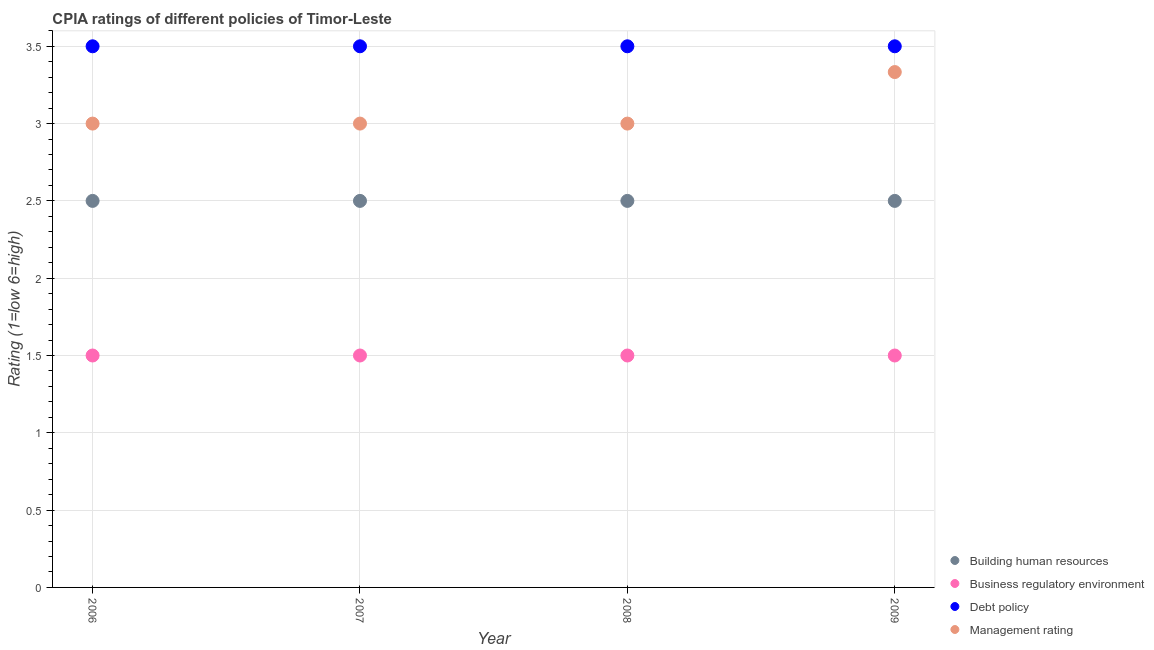How many different coloured dotlines are there?
Provide a short and direct response. 4. What is the cpia rating of building human resources in 2006?
Offer a very short reply. 2.5. Across all years, what is the maximum cpia rating of debt policy?
Your answer should be compact. 3.5. Across all years, what is the minimum cpia rating of debt policy?
Provide a short and direct response. 3.5. In which year was the cpia rating of debt policy maximum?
Give a very brief answer. 2006. In which year was the cpia rating of management minimum?
Ensure brevity in your answer.  2006. What is the total cpia rating of management in the graph?
Provide a succinct answer. 12.33. What is the average cpia rating of management per year?
Give a very brief answer. 3.08. What is the ratio of the cpia rating of debt policy in 2006 to that in 2008?
Provide a short and direct response. 1. Is the cpia rating of management in 2006 less than that in 2008?
Your answer should be compact. No. Is the difference between the cpia rating of building human resources in 2006 and 2008 greater than the difference between the cpia rating of business regulatory environment in 2006 and 2008?
Make the answer very short. No. What is the difference between the highest and the second highest cpia rating of business regulatory environment?
Keep it short and to the point. 0. What is the difference between the highest and the lowest cpia rating of building human resources?
Your response must be concise. 0. In how many years, is the cpia rating of management greater than the average cpia rating of management taken over all years?
Give a very brief answer. 1. Is the sum of the cpia rating of management in 2006 and 2009 greater than the maximum cpia rating of building human resources across all years?
Provide a succinct answer. Yes. Does the cpia rating of management monotonically increase over the years?
Provide a short and direct response. No. Is the cpia rating of debt policy strictly greater than the cpia rating of business regulatory environment over the years?
Keep it short and to the point. Yes. How many dotlines are there?
Provide a succinct answer. 4. How many years are there in the graph?
Your answer should be compact. 4. What is the difference between two consecutive major ticks on the Y-axis?
Ensure brevity in your answer.  0.5. Does the graph contain any zero values?
Ensure brevity in your answer.  No. How are the legend labels stacked?
Provide a succinct answer. Vertical. What is the title of the graph?
Provide a short and direct response. CPIA ratings of different policies of Timor-Leste. Does "Finland" appear as one of the legend labels in the graph?
Ensure brevity in your answer.  No. What is the label or title of the X-axis?
Provide a short and direct response. Year. What is the label or title of the Y-axis?
Make the answer very short. Rating (1=low 6=high). What is the Rating (1=low 6=high) of Building human resources in 2006?
Offer a very short reply. 2.5. What is the Rating (1=low 6=high) of Business regulatory environment in 2006?
Make the answer very short. 1.5. What is the Rating (1=low 6=high) of Building human resources in 2007?
Make the answer very short. 2.5. What is the Rating (1=low 6=high) in Debt policy in 2007?
Keep it short and to the point. 3.5. What is the Rating (1=low 6=high) in Management rating in 2007?
Ensure brevity in your answer.  3. What is the Rating (1=low 6=high) in Building human resources in 2008?
Keep it short and to the point. 2.5. What is the Rating (1=low 6=high) in Debt policy in 2008?
Keep it short and to the point. 3.5. What is the Rating (1=low 6=high) of Building human resources in 2009?
Provide a succinct answer. 2.5. What is the Rating (1=low 6=high) in Business regulatory environment in 2009?
Ensure brevity in your answer.  1.5. What is the Rating (1=low 6=high) of Management rating in 2009?
Your answer should be very brief. 3.33. Across all years, what is the maximum Rating (1=low 6=high) of Business regulatory environment?
Offer a terse response. 1.5. Across all years, what is the maximum Rating (1=low 6=high) in Debt policy?
Offer a terse response. 3.5. Across all years, what is the maximum Rating (1=low 6=high) in Management rating?
Your response must be concise. 3.33. What is the total Rating (1=low 6=high) of Debt policy in the graph?
Make the answer very short. 14. What is the total Rating (1=low 6=high) of Management rating in the graph?
Your answer should be compact. 12.33. What is the difference between the Rating (1=low 6=high) of Management rating in 2006 and that in 2007?
Ensure brevity in your answer.  0. What is the difference between the Rating (1=low 6=high) in Debt policy in 2006 and that in 2008?
Provide a succinct answer. 0. What is the difference between the Rating (1=low 6=high) in Debt policy in 2006 and that in 2009?
Your response must be concise. 0. What is the difference between the Rating (1=low 6=high) of Management rating in 2006 and that in 2009?
Offer a very short reply. -0.33. What is the difference between the Rating (1=low 6=high) in Building human resources in 2007 and that in 2008?
Your response must be concise. 0. What is the difference between the Rating (1=low 6=high) of Business regulatory environment in 2007 and that in 2008?
Your answer should be compact. 0. What is the difference between the Rating (1=low 6=high) of Debt policy in 2007 and that in 2008?
Your response must be concise. 0. What is the difference between the Rating (1=low 6=high) of Debt policy in 2007 and that in 2009?
Provide a short and direct response. 0. What is the difference between the Rating (1=low 6=high) of Management rating in 2007 and that in 2009?
Provide a short and direct response. -0.33. What is the difference between the Rating (1=low 6=high) of Business regulatory environment in 2008 and that in 2009?
Ensure brevity in your answer.  0. What is the difference between the Rating (1=low 6=high) in Building human resources in 2006 and the Rating (1=low 6=high) in Business regulatory environment in 2007?
Make the answer very short. 1. What is the difference between the Rating (1=low 6=high) of Building human resources in 2006 and the Rating (1=low 6=high) of Debt policy in 2007?
Provide a short and direct response. -1. What is the difference between the Rating (1=low 6=high) of Building human resources in 2006 and the Rating (1=low 6=high) of Management rating in 2007?
Make the answer very short. -0.5. What is the difference between the Rating (1=low 6=high) of Business regulatory environment in 2006 and the Rating (1=low 6=high) of Debt policy in 2007?
Give a very brief answer. -2. What is the difference between the Rating (1=low 6=high) of Debt policy in 2006 and the Rating (1=low 6=high) of Management rating in 2007?
Offer a very short reply. 0.5. What is the difference between the Rating (1=low 6=high) in Building human resources in 2006 and the Rating (1=low 6=high) in Debt policy in 2008?
Offer a terse response. -1. What is the difference between the Rating (1=low 6=high) of Debt policy in 2006 and the Rating (1=low 6=high) of Management rating in 2008?
Provide a short and direct response. 0.5. What is the difference between the Rating (1=low 6=high) in Building human resources in 2006 and the Rating (1=low 6=high) in Business regulatory environment in 2009?
Provide a short and direct response. 1. What is the difference between the Rating (1=low 6=high) of Building human resources in 2006 and the Rating (1=low 6=high) of Management rating in 2009?
Ensure brevity in your answer.  -0.83. What is the difference between the Rating (1=low 6=high) of Business regulatory environment in 2006 and the Rating (1=low 6=high) of Debt policy in 2009?
Your response must be concise. -2. What is the difference between the Rating (1=low 6=high) of Business regulatory environment in 2006 and the Rating (1=low 6=high) of Management rating in 2009?
Your answer should be compact. -1.83. What is the difference between the Rating (1=low 6=high) in Debt policy in 2006 and the Rating (1=low 6=high) in Management rating in 2009?
Your answer should be compact. 0.17. What is the difference between the Rating (1=low 6=high) of Business regulatory environment in 2007 and the Rating (1=low 6=high) of Debt policy in 2008?
Keep it short and to the point. -2. What is the difference between the Rating (1=low 6=high) of Debt policy in 2007 and the Rating (1=low 6=high) of Management rating in 2008?
Provide a short and direct response. 0.5. What is the difference between the Rating (1=low 6=high) in Building human resources in 2007 and the Rating (1=low 6=high) in Business regulatory environment in 2009?
Provide a succinct answer. 1. What is the difference between the Rating (1=low 6=high) in Building human resources in 2007 and the Rating (1=low 6=high) in Debt policy in 2009?
Provide a short and direct response. -1. What is the difference between the Rating (1=low 6=high) of Building human resources in 2007 and the Rating (1=low 6=high) of Management rating in 2009?
Offer a very short reply. -0.83. What is the difference between the Rating (1=low 6=high) of Business regulatory environment in 2007 and the Rating (1=low 6=high) of Management rating in 2009?
Offer a very short reply. -1.83. What is the difference between the Rating (1=low 6=high) of Building human resources in 2008 and the Rating (1=low 6=high) of Debt policy in 2009?
Offer a very short reply. -1. What is the difference between the Rating (1=low 6=high) of Building human resources in 2008 and the Rating (1=low 6=high) of Management rating in 2009?
Provide a short and direct response. -0.83. What is the difference between the Rating (1=low 6=high) of Business regulatory environment in 2008 and the Rating (1=low 6=high) of Management rating in 2009?
Give a very brief answer. -1.83. What is the difference between the Rating (1=low 6=high) in Debt policy in 2008 and the Rating (1=low 6=high) in Management rating in 2009?
Make the answer very short. 0.17. What is the average Rating (1=low 6=high) of Building human resources per year?
Offer a terse response. 2.5. What is the average Rating (1=low 6=high) in Management rating per year?
Make the answer very short. 3.08. In the year 2006, what is the difference between the Rating (1=low 6=high) in Building human resources and Rating (1=low 6=high) in Business regulatory environment?
Provide a succinct answer. 1. In the year 2006, what is the difference between the Rating (1=low 6=high) in Business regulatory environment and Rating (1=low 6=high) in Debt policy?
Your answer should be compact. -2. In the year 2007, what is the difference between the Rating (1=low 6=high) in Building human resources and Rating (1=low 6=high) in Business regulatory environment?
Provide a succinct answer. 1. In the year 2007, what is the difference between the Rating (1=low 6=high) of Building human resources and Rating (1=low 6=high) of Debt policy?
Ensure brevity in your answer.  -1. In the year 2007, what is the difference between the Rating (1=low 6=high) of Business regulatory environment and Rating (1=low 6=high) of Debt policy?
Your answer should be compact. -2. In the year 2007, what is the difference between the Rating (1=low 6=high) in Debt policy and Rating (1=low 6=high) in Management rating?
Your response must be concise. 0.5. In the year 2008, what is the difference between the Rating (1=low 6=high) of Building human resources and Rating (1=low 6=high) of Management rating?
Offer a terse response. -0.5. In the year 2008, what is the difference between the Rating (1=low 6=high) in Business regulatory environment and Rating (1=low 6=high) in Debt policy?
Provide a short and direct response. -2. In the year 2008, what is the difference between the Rating (1=low 6=high) of Business regulatory environment and Rating (1=low 6=high) of Management rating?
Give a very brief answer. -1.5. In the year 2009, what is the difference between the Rating (1=low 6=high) of Building human resources and Rating (1=low 6=high) of Debt policy?
Offer a terse response. -1. In the year 2009, what is the difference between the Rating (1=low 6=high) in Business regulatory environment and Rating (1=low 6=high) in Debt policy?
Keep it short and to the point. -2. In the year 2009, what is the difference between the Rating (1=low 6=high) in Business regulatory environment and Rating (1=low 6=high) in Management rating?
Your answer should be compact. -1.83. In the year 2009, what is the difference between the Rating (1=low 6=high) of Debt policy and Rating (1=low 6=high) of Management rating?
Offer a very short reply. 0.17. What is the ratio of the Rating (1=low 6=high) of Building human resources in 2006 to that in 2007?
Your answer should be compact. 1. What is the ratio of the Rating (1=low 6=high) in Business regulatory environment in 2006 to that in 2007?
Offer a very short reply. 1. What is the ratio of the Rating (1=low 6=high) of Debt policy in 2006 to that in 2007?
Keep it short and to the point. 1. What is the ratio of the Rating (1=low 6=high) of Building human resources in 2006 to that in 2008?
Offer a very short reply. 1. What is the ratio of the Rating (1=low 6=high) in Business regulatory environment in 2006 to that in 2008?
Your answer should be very brief. 1. What is the ratio of the Rating (1=low 6=high) of Management rating in 2006 to that in 2008?
Offer a terse response. 1. What is the ratio of the Rating (1=low 6=high) in Debt policy in 2006 to that in 2009?
Provide a succinct answer. 1. What is the ratio of the Rating (1=low 6=high) of Management rating in 2006 to that in 2009?
Offer a very short reply. 0.9. What is the ratio of the Rating (1=low 6=high) in Building human resources in 2007 to that in 2008?
Your answer should be very brief. 1. What is the ratio of the Rating (1=low 6=high) in Management rating in 2007 to that in 2008?
Offer a terse response. 1. What is the ratio of the Rating (1=low 6=high) in Building human resources in 2007 to that in 2009?
Give a very brief answer. 1. What is the ratio of the Rating (1=low 6=high) in Debt policy in 2007 to that in 2009?
Your answer should be very brief. 1. What is the ratio of the Rating (1=low 6=high) in Management rating in 2007 to that in 2009?
Your response must be concise. 0.9. What is the ratio of the Rating (1=low 6=high) in Building human resources in 2008 to that in 2009?
Make the answer very short. 1. What is the ratio of the Rating (1=low 6=high) of Management rating in 2008 to that in 2009?
Give a very brief answer. 0.9. What is the difference between the highest and the second highest Rating (1=low 6=high) of Building human resources?
Keep it short and to the point. 0. What is the difference between the highest and the second highest Rating (1=low 6=high) in Business regulatory environment?
Offer a terse response. 0. What is the difference between the highest and the lowest Rating (1=low 6=high) in Building human resources?
Provide a short and direct response. 0. 